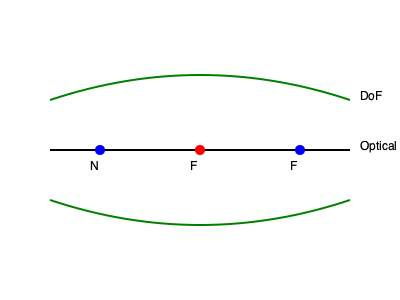In your garage studio, you're photographing a subject at a focus distance of 2 meters using a 50mm lens with an aperture of f/4. Given that the circle of confusion for your camera is 0.03mm, calculate the depth of field. Use the diagram as a reference, where F represents the focal point, N is the near limit, and F is the far limit of the depth of field. To calculate the depth of field, we'll use the following steps:

1. Calculate the hyperfocal distance (H):
   $$H = \frac{f^2}{N \cdot c} + f$$
   where f is focal length, N is f-number, and c is circle of confusion
   $$H = \frac{50^2}{4 \cdot 0.03} + 50 = 20.83 + 50 = 70.83 \text{ m}$$

2. Calculate the near limit (D_n):
   $$D_n = \frac{s \cdot (H - f)}{H + s - 2f}$$
   where s is the focus distance
   $$D_n = \frac{2 \cdot (70.83 - 0.05)}{70.83 + 2 - 0.1} = \frac{141.56}{72.73} = 1.95 \text{ m}$$

3. Calculate the far limit (D_f):
   $$D_f = \frac{s \cdot (H - f)}{H - s}$$
   $$D_f = \frac{2 \cdot (70.83 - 0.05)}{70.83 - 2} = \frac{141.56}{68.83} = 2.06 \text{ m}$$

4. Calculate the total depth of field:
   DoF = Far limit - Near limit
   $$\text{DoF} = 2.06 - 1.95 = 0.11 \text{ m} = 11 \text{ cm}$$
Answer: 11 cm 